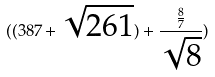Convert formula to latex. <formula><loc_0><loc_0><loc_500><loc_500>( ( 3 8 7 + \sqrt { 2 6 1 } ) + \frac { \frac { 8 } { 7 } } { \sqrt { 8 } } )</formula> 